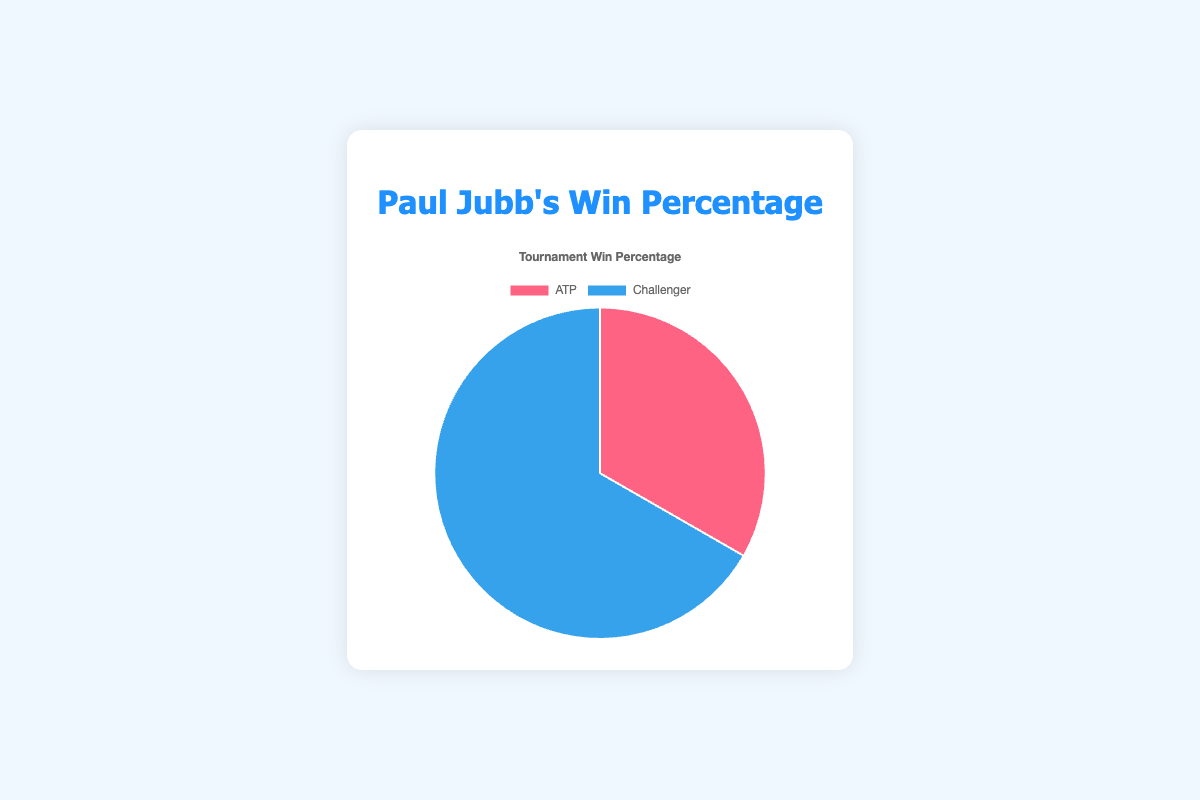Which tournament type has the higher win percentage for Paul Jubb? The chart shows win percentages for ATP and Challenger tournaments. By visually comparing the two slices, we see that the Challenger slice is larger. This indicates a higher win percentage for the Challenger tournaments.
Answer: Challenger What is the win percentage for ATP tournaments? The chart shows that the win percentage for ATP tournaments is represented by the red slice. According to the legend, the ATP win percentage is 33.3%.
Answer: 33.3% How many more matches has Paul Jubb won in Challenger tournaments compared to ATP tournaments? From the data, Paul Jubb has won 20 matches in Challenger tournaments and 5 matches in ATP tournaments. The difference is calculated as 20 - 5.
Answer: 15 What is the combined win percentage for all tournaments? To find the combined win percentage, we sum the matches and wins, and then calculate the ratio. Total matches = 15 (ATP) + 30 (Challenger) = 45. Total wins = 5 (ATP) + 20 (Challenger) = 25. The combined win percentage is (25/45)*100.
Answer: 55.6% Which color represents the higher win percentage in the pie chart? The chart uses colors to represent tournament types. By looking at the larger slice in blue, you can see that it represents the Challenger tournaments, which have a higher win percentage.
Answer: Blue By what factor is the win percentage higher in Challenger tournaments compared to ATP tournaments? The win percentage for Challenger tournaments is 66.7% and for ATP tournaments is 33.3%. To find the factor, you divide 66.7 by 33.3.
Answer: 2 What percentage of Paul Jubb's total wins were in Challenger tournaments? Paul Jubb has 25 total wins and 20 of these were in Challenger tournaments. To find the percentage, calculate (20/25)*100.
Answer: 80% What is the win percentage gap between ATP and Challenger tournaments? The win percentage for ATP tournaments is 33.3%, and for Challenger tournaments, it is 66.7%. The gap is calculated as 66.7 - 33.3.
Answer: 33.4% What fraction of the pie chart is taken up by Challenger tournaments? Since the chart represents win percentages, and Challenger tournaments have a 66.7% win rate, this translates directly to the fraction of the chart. This is 66.7/100 or 2/3 of the pie chart.
Answer: 2/3 